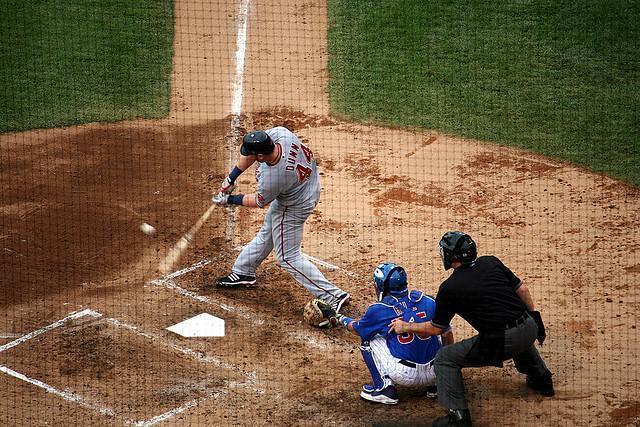What is number 44 doing?
Make your selection and explain in format: 'Answer: answer
Rationale: rationale.'
Options: Running away, sliding down, hitting ball, swinging bat. Answer: swinging bat.
Rationale: We don't know if the batter will make contact with the ball, so "b" can't be right.  the other two options make no sense. 